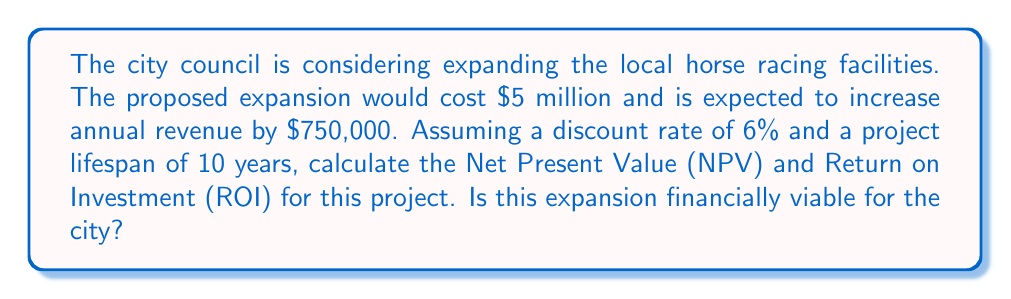Solve this math problem. To determine if the expansion is financially viable, we need to calculate the Net Present Value (NPV) and Return on Investment (ROI).

Step 1: Calculate the Present Value of Future Cash Flows
The present value of future cash flows can be calculated using the following formula:

$$ PV = \sum_{t=1}^{n} \frac{CF_t}{(1+r)^t} $$

Where:
$CF_t$ = Cash flow in year t
$r$ = Discount rate
$n$ = Number of years

For our case:
$CF_t$ = $750,000 (annual revenue increase)
$r$ = 6% = 0.06
$n$ = 10 years

$$ PV = 750,000 \times \frac{1-(1+0.06)^{-10}}{0.06} = 5,519,905.62 $$

Step 2: Calculate Net Present Value (NPV)
NPV is the difference between the present value of cash inflows and the present value of cash outflows.

$$ NPV = PV - Initial Investment $$
$$ NPV = 5,519,905.62 - 5,000,000 = 519,905.62 $$

Step 3: Calculate Return on Investment (ROI)
ROI is calculated as:

$$ ROI = \frac{Net Profit}{Cost of Investment} \times 100\% $$

In this case, we'll use the NPV as the net profit:

$$ ROI = \frac{519,905.62}{5,000,000} \times 100\% = 10.40\% $$
Answer: The Net Present Value (NPV) of the project is $519,905.62, and the Return on Investment (ROI) is 10.40%. Since the NPV is positive and the ROI is greater than the discount rate of 6%, the expansion project is financially viable for the city. 